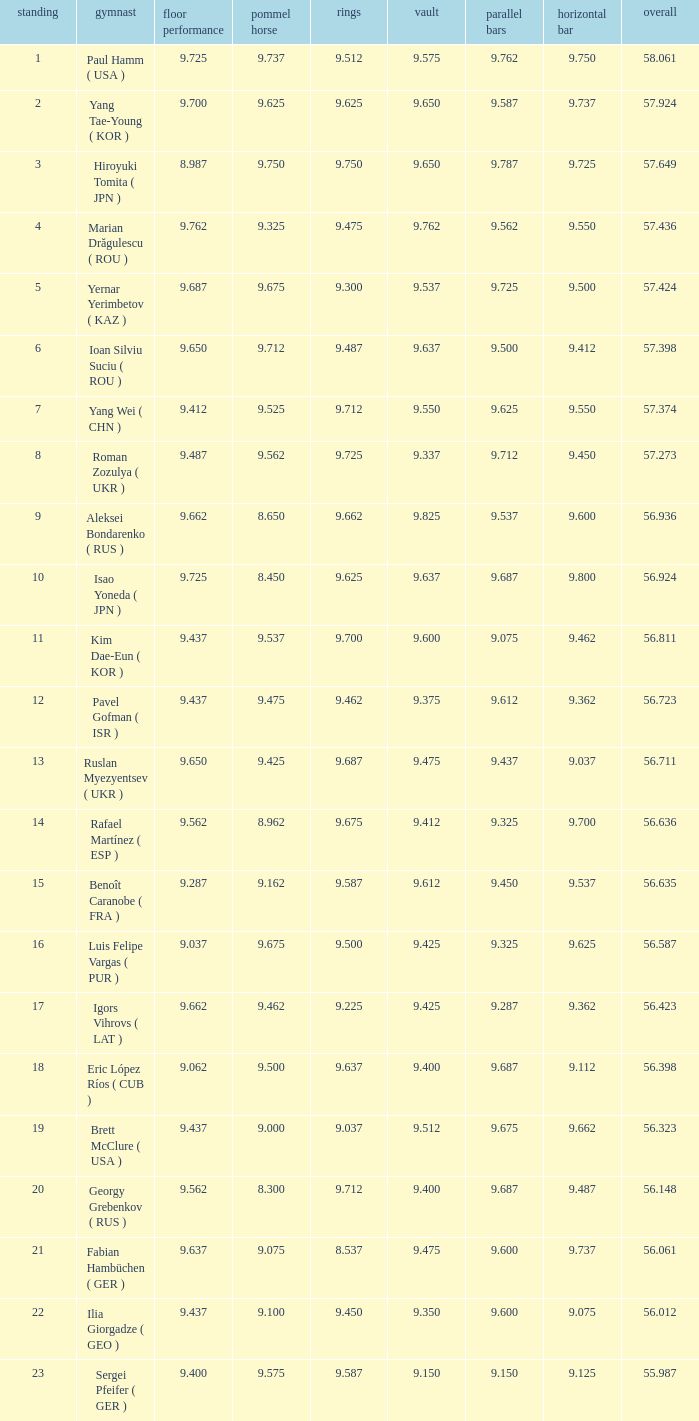What is the vault score for the total of 56.635? 9.612. 